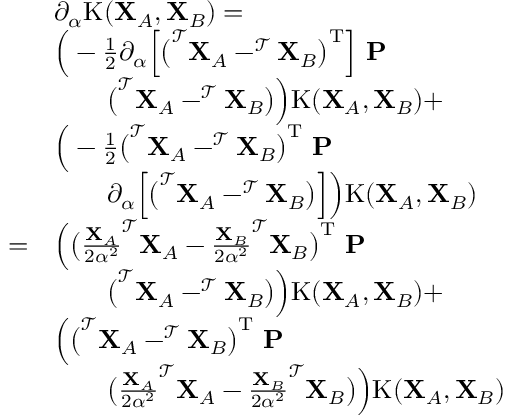Convert formula to latex. <formula><loc_0><loc_0><loc_500><loc_500>\begin{array} { r l } & { \partial _ { \alpha } K ( X _ { A } , X _ { B } ) = } \\ & { \left ( - \frac { 1 } { 2 } \partial _ { \alpha } \left [ \left ( ^ { \mathcal { T } } X _ { A } - ^ { \mathcal { T } } X _ { B } \right ) ^ { T } \right ] \ P } \\ & { \quad \left ( ^ { \mathcal { T } } X _ { A } - ^ { \mathcal { T } } X _ { B } \right ) \right ) K ( X _ { A } , X _ { B } ) + } \\ & { \left ( - \frac { 1 } { 2 } \left ( ^ { \mathcal { T } } X _ { A } - ^ { \mathcal { T } } X _ { B } \right ) ^ { T } \ P } \\ & { \quad \partial _ { \alpha } \left [ \left ( ^ { \mathcal { T } } X _ { A } - ^ { \mathcal { T } } X _ { B } \right ) \right ] \right ) K ( X _ { A } , X _ { B } ) } \\ { = } & { \left ( \left ( \frac { X _ { A } } { 2 \alpha ^ { 2 } } ^ { \mathcal { T } } X _ { A } - \frac { X _ { B } } { 2 \alpha ^ { 2 } } ^ { \mathcal { T } } X _ { B } \right ) ^ { T } \ P } \\ & { \quad \left ( ^ { \mathcal { T } } X _ { A } - ^ { \mathcal { T } } X _ { B } \right ) \right ) K ( X _ { A } , X _ { B } ) + } \\ & { \left ( \left ( ^ { \mathcal { T } } X _ { A } - ^ { \mathcal { T } } X _ { B } \right ) ^ { T } \ P } \\ & { \quad \left ( \frac { X _ { A } } { 2 \alpha ^ { 2 } } ^ { \mathcal { T } } X _ { A } - \frac { X _ { B } } { 2 \alpha ^ { 2 } } ^ { \mathcal { T } } X _ { B } \right ) \right ) K ( X _ { A } , X _ { B } ) } \end{array}</formula> 